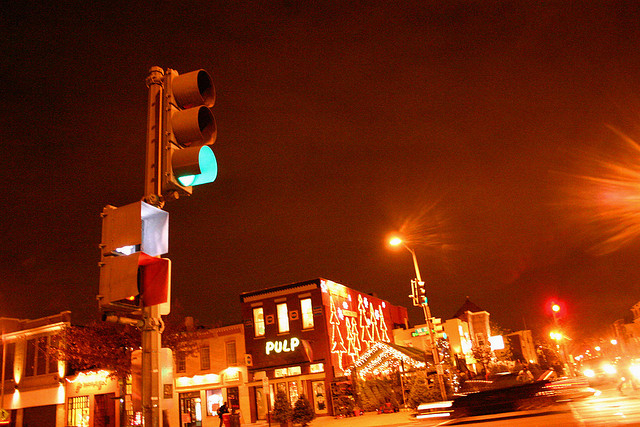Please transcribe the text in this image. PULP 